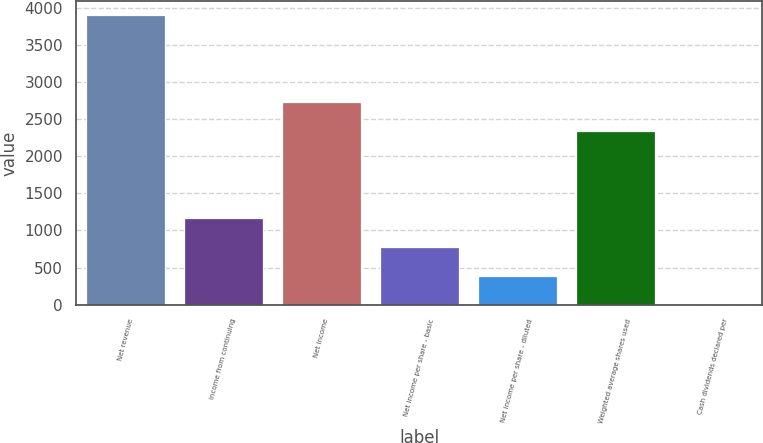<chart> <loc_0><loc_0><loc_500><loc_500><bar_chart><fcel>Net revenue<fcel>Income from continuing<fcel>Net income<fcel>Net income per share - basic<fcel>Net income per share - diluted<fcel>Weighted average shares used<fcel>Cash dividends declared per<nl><fcel>3894<fcel>1168.51<fcel>2725.91<fcel>779.16<fcel>389.81<fcel>2336.56<fcel>0.46<nl></chart> 